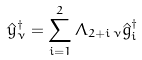<formula> <loc_0><loc_0><loc_500><loc_500>\hat { y } _ { \nu } ^ { \dagger } = \sum _ { i = 1 } ^ { 2 } \Lambda _ { 2 + i \, \nu } \hat { g } _ { i } ^ { \dagger }</formula> 